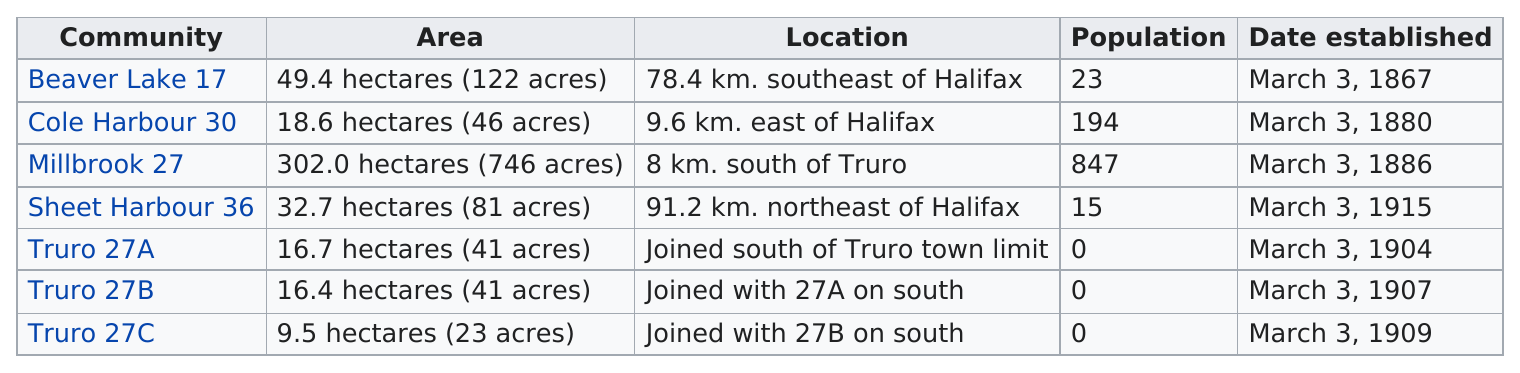Point out several critical features in this image. The community with the largest population is Millbrook, with 27 people. According to the provided information, there are two communities named Cole Harbour and Millbrook that have a population of at least 100 people each. The community with the largest area is Millbrook, covering 27 square kilometers. Truro 27C is the community with the least number of acres. The community with the largest area in acres is Millbrook, with 27 acres. 